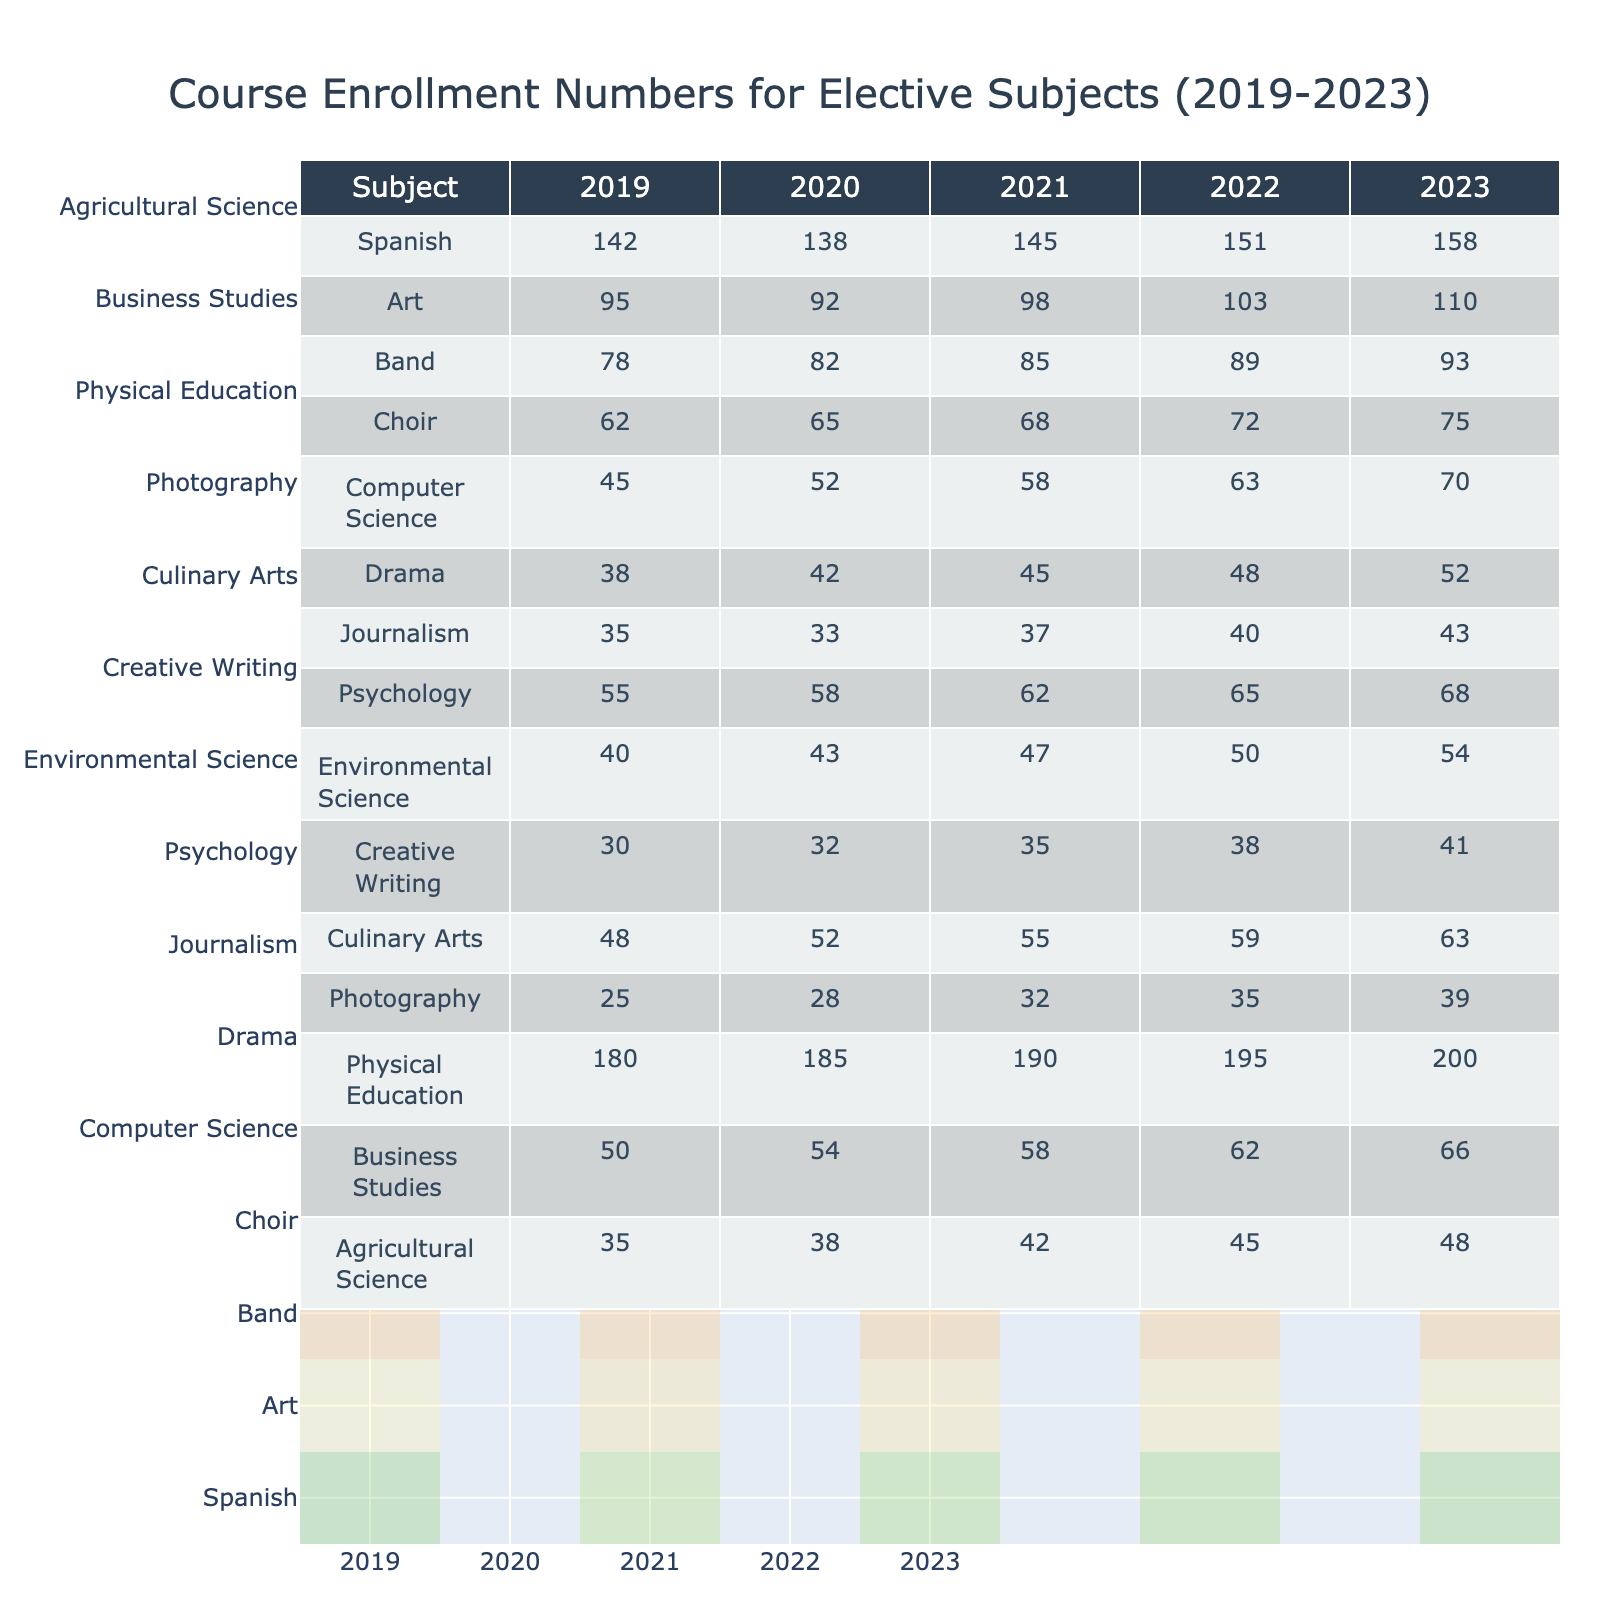What was the enrollment number for Choir in 2022? The table shows the enrollment numbers for various subjects in each year. Looking under the Choir column for the year 2022, the value is 72.
Answer: 72 Which subject experienced the highest enrollment number in 2023? By examining the last column for 2023, Physical Education has the highest enrollment number, which is 200.
Answer: Physical Education What is the difference in enrollment numbers for Spanish between 2019 and 2023? The Spanish enrollment numbers in 2019 and 2023 are 142 and 158, respectively. The difference is calculated by subtracting 142 from 158, which equals 16.
Answer: 16 What are the average enrollment numbers for Art over the last 5 years? The enrollment numbers for Art from 2019 to 2023 are 95, 92, 98, 103, and 110. Summing these values gives 498, and dividing by 5 (the number of years) gives an average of 99.6.
Answer: 99.6 Did Computer Science see an increase in enrollment from 2022 to 2023? The enrollment for Computer Science in 2022 was 63 and in 2023 it was 70. Since 70 is greater than 63, this confirms an increase in enrollment.
Answer: Yes Comparing the enrollment numbers for Drama in 2019 and 2023, what can be said about its growth? The Drama enrollment was 38 in 2019 and 52 in 2023. The increase is calculated as 52 minus 38, which is 14, indicating a positive growth trend.
Answer: It grew by 14 What was the total enrollment across all subjects in 2023? To find the total enrollment in 2023, the individual numbers are summed: 158 + 110 + 93 + 75 + 70 + 52 + 43 + 68 + 54 + 41 + 63 + 39 + 200 + 66 + 48 = 1,183.
Answer: 1,183 Is it true that Journalism had a higher enrollment than Psychology in any year? In the table, Journalism enrollments were 35, 33, 37, 40, and 43, while Psychology enrollments were 55, 58, 62, 65, and 68. Since Journalism was lower in all years compared to Psychology, this statement is false.
Answer: No Which elective subject saw the largest increase in enrollment over the five years? By examining the differences, Physical Education increased from 180 to 200, an increase of 20, while other subjects had smaller increases. Therefore, Physical Education had the largest increase.
Answer: Physical Education How did Culinary Arts enrollment in 2021 compare to the average enrollment of the previous four years? The enrollment for Culinary Arts in 2021 was 55. The average for the previous four years (48, 52, 59, 63) is (48 + 52 + 59 + 63) / 4 = 55.5. Since 55 is less than 55.5, the 2021 enrollment was lower than the average.
Answer: Lower In what year did Band reach an enrollment of 89? Looking at the Band column, the enrollment number reached 89 in the year 2022.
Answer: 2022 